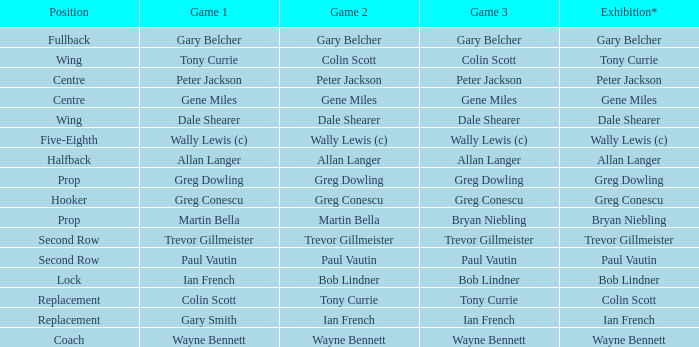What game 1 has bob lindner as game 2? Ian French. 